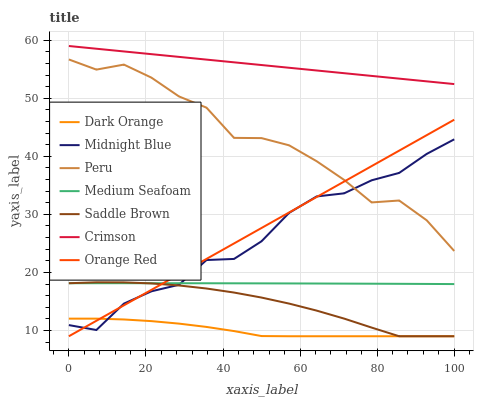Does Dark Orange have the minimum area under the curve?
Answer yes or no. Yes. Does Crimson have the maximum area under the curve?
Answer yes or no. Yes. Does Midnight Blue have the minimum area under the curve?
Answer yes or no. No. Does Midnight Blue have the maximum area under the curve?
Answer yes or no. No. Is Crimson the smoothest?
Answer yes or no. Yes. Is Midnight Blue the roughest?
Answer yes or no. Yes. Is Orange Red the smoothest?
Answer yes or no. No. Is Orange Red the roughest?
Answer yes or no. No. Does Dark Orange have the lowest value?
Answer yes or no. Yes. Does Midnight Blue have the lowest value?
Answer yes or no. No. Does Crimson have the highest value?
Answer yes or no. Yes. Does Midnight Blue have the highest value?
Answer yes or no. No. Is Dark Orange less than Crimson?
Answer yes or no. Yes. Is Crimson greater than Peru?
Answer yes or no. Yes. Does Medium Seafoam intersect Saddle Brown?
Answer yes or no. Yes. Is Medium Seafoam less than Saddle Brown?
Answer yes or no. No. Is Medium Seafoam greater than Saddle Brown?
Answer yes or no. No. Does Dark Orange intersect Crimson?
Answer yes or no. No. 